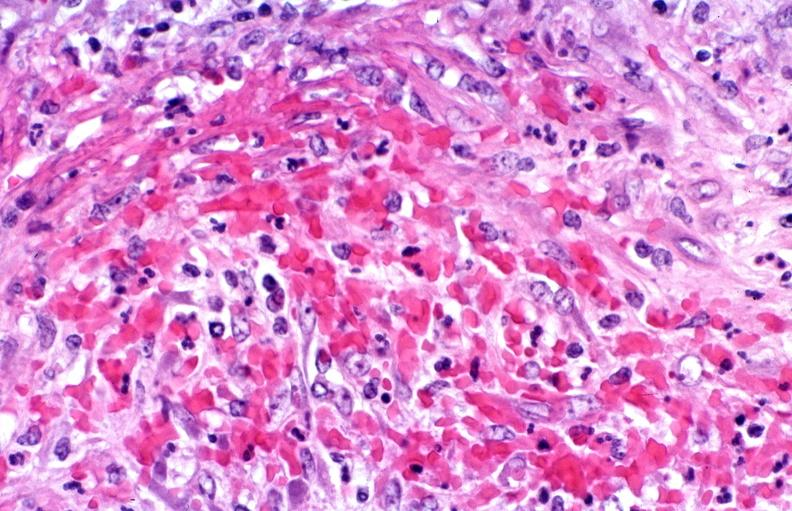what does this image show?
Answer the question using a single word or phrase. Polyarteritis nodosa 